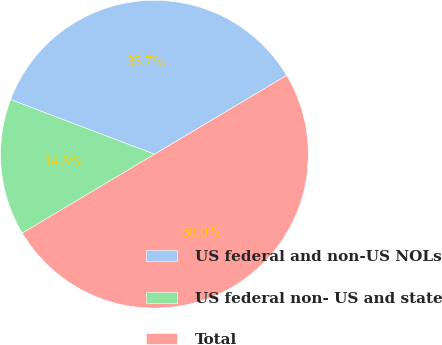Convert chart. <chart><loc_0><loc_0><loc_500><loc_500><pie_chart><fcel>US federal and non-US NOLs<fcel>US federal non- US and state<fcel>Total<nl><fcel>35.66%<fcel>14.34%<fcel>50.0%<nl></chart> 